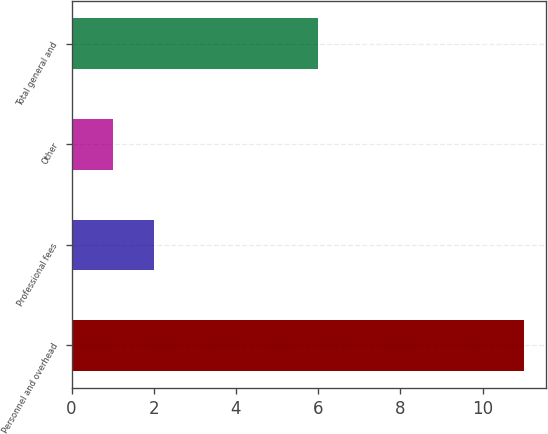<chart> <loc_0><loc_0><loc_500><loc_500><bar_chart><fcel>Personnel and overhead<fcel>Professional fees<fcel>Other<fcel>Total general and<nl><fcel>11<fcel>2<fcel>1<fcel>6<nl></chart> 